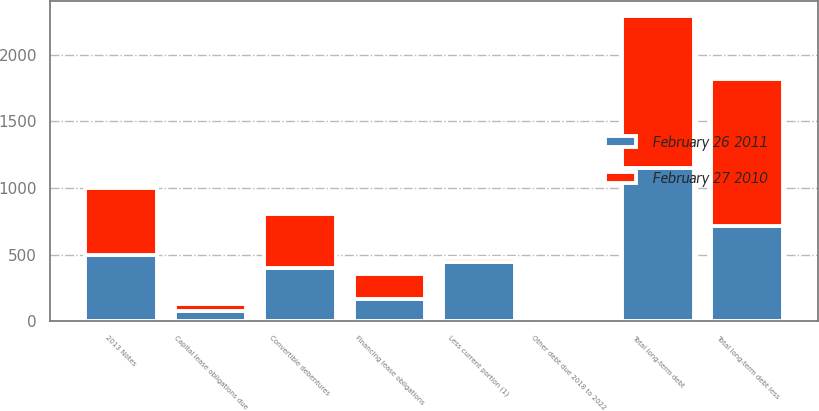Convert chart. <chart><loc_0><loc_0><loc_500><loc_500><stacked_bar_chart><ecel><fcel>2013 Notes<fcel>Convertible debentures<fcel>Financing lease obligations<fcel>Capital lease obligations due<fcel>Other debt due 2018 to 2022<fcel>Total long-term debt<fcel>Less current portion (1)<fcel>Total long-term debt less<nl><fcel>February 26 2011<fcel>500<fcel>402<fcel>170<fcel>79<fcel>1<fcel>1152<fcel>441<fcel>711<nl><fcel>February 27 2010<fcel>500<fcel>402<fcel>186<fcel>49<fcel>2<fcel>1139<fcel>35<fcel>1104<nl></chart> 